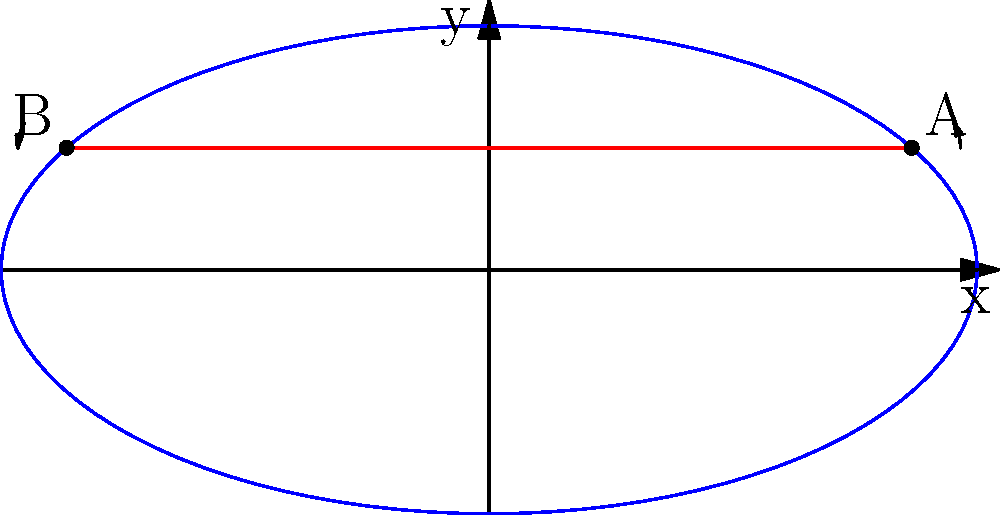On an oval NASCAR track represented by the polar equation $r(\theta) = \frac{ab}{\sqrt{(b\cos\theta)^2 + (a\sin\theta)^2}}$, where $a=2$ and $b=1$, you need to determine the fastest route between points A at $\theta_1 = \frac{\pi}{6}$ and B at $\theta_2 = \frac{5\pi}{6}$. Which path is shorter: the direct line between A and B, or the arc along the track? Calculate the difference in length between these two paths. To solve this problem, we need to calculate and compare the lengths of two paths:

1. The direct line (chord) between A and B
2. The arc along the track from A to B

Step 1: Calculate the coordinates of points A and B
A: $(\frac{2\sqrt{3}}{2}, \frac{1}{2})$
B: $(-\frac{2\sqrt{3}}{2}, \frac{1}{2})$

Step 2: Calculate the length of the direct line (chord)
Using the distance formula:
$d = \sqrt{(x_2-x_1)^2 + (y_2-y_1)^2}$
$d = \sqrt{(-\frac{2\sqrt{3}}{2} - \frac{2\sqrt{3}}{2})^2 + (\frac{1}{2} - \frac{1}{2})^2}$
$d = \sqrt{(-2\sqrt{3})^2} = 2\sqrt{3} \approx 3.464$

Step 3: Calculate the length of the arc
The arc length in polar form is given by:
$s = \int_{\theta_1}^{\theta_2} \sqrt{r^2 + (\frac{dr}{d\theta})^2} d\theta$

For the given equation:
$\frac{dr}{d\theta} = \frac{a^2b^2(b^2-a^2)\sin\theta\cos\theta}{(b^2\cos^2\theta + a^2\sin^2\theta)^{3/2}}$

Substituting and evaluating the integral:
$s = \int_{\pi/6}^{5\pi/6} \sqrt{\frac{a^2b^2}{b^2\cos^2\theta + a^2\sin^2\theta} + \frac{a^4b^4(b^2-a^2)^2\sin^2\theta\cos^2\theta}{(b^2\cos^2\theta + a^2\sin^2\theta)^3}} d\theta$

This integral is complex and typically requires numerical methods to solve. Using numerical integration, we get:
$s \approx 3.858$

Step 4: Calculate the difference
Difference = Arc length - Chord length
$3.858 - 3.464 = 0.394$

Therefore, the arc along the track is approximately 0.394 units longer than the direct line.
Answer: The arc is 0.394 units longer than the direct line. 